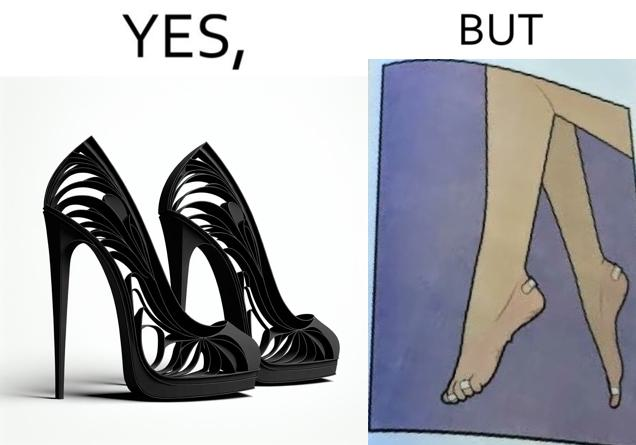What is the satirical meaning behind this image? The images are funny since they show how the prettiest footwears like high heels, end up causing a lot of physical discomfort to the user, all in the name fashion 